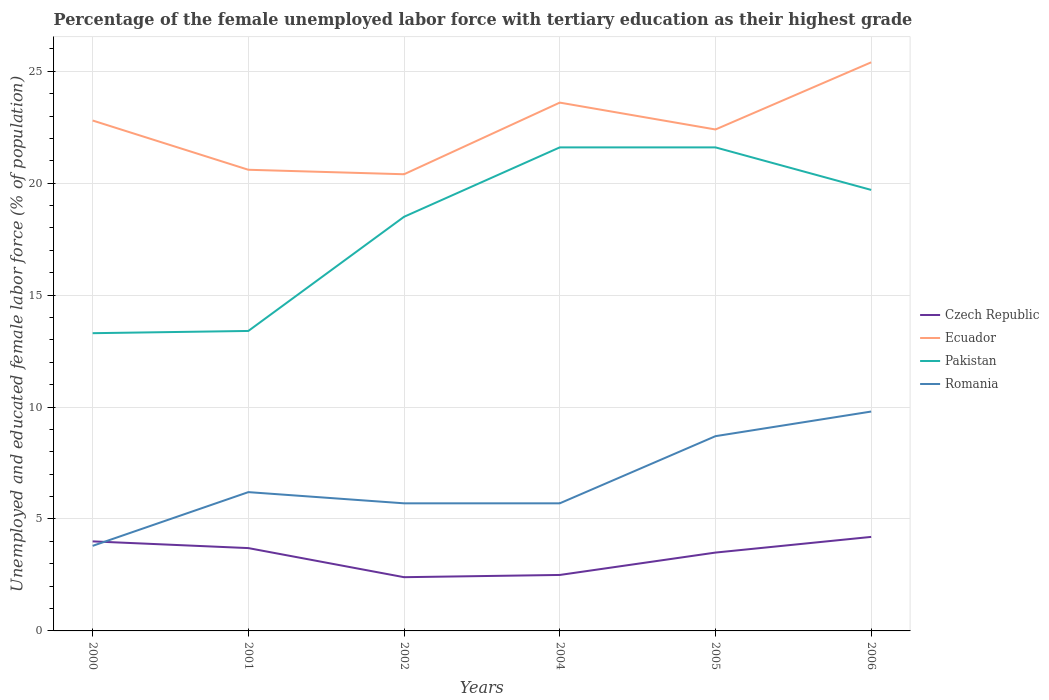How many different coloured lines are there?
Your answer should be compact. 4. Across all years, what is the maximum percentage of the unemployed female labor force with tertiary education in Romania?
Your answer should be compact. 3.8. What is the total percentage of the unemployed female labor force with tertiary education in Pakistan in the graph?
Make the answer very short. -6.4. What is the difference between the highest and the second highest percentage of the unemployed female labor force with tertiary education in Romania?
Provide a succinct answer. 6. What is the difference between the highest and the lowest percentage of the unemployed female labor force with tertiary education in Romania?
Your answer should be very brief. 2. How many years are there in the graph?
Give a very brief answer. 6. What is the difference between two consecutive major ticks on the Y-axis?
Ensure brevity in your answer.  5. Does the graph contain grids?
Offer a terse response. Yes. How many legend labels are there?
Ensure brevity in your answer.  4. How are the legend labels stacked?
Provide a short and direct response. Vertical. What is the title of the graph?
Provide a succinct answer. Percentage of the female unemployed labor force with tertiary education as their highest grade. What is the label or title of the X-axis?
Provide a succinct answer. Years. What is the label or title of the Y-axis?
Ensure brevity in your answer.  Unemployed and educated female labor force (% of population). What is the Unemployed and educated female labor force (% of population) of Ecuador in 2000?
Offer a very short reply. 22.8. What is the Unemployed and educated female labor force (% of population) in Pakistan in 2000?
Make the answer very short. 13.3. What is the Unemployed and educated female labor force (% of population) in Romania in 2000?
Ensure brevity in your answer.  3.8. What is the Unemployed and educated female labor force (% of population) of Czech Republic in 2001?
Ensure brevity in your answer.  3.7. What is the Unemployed and educated female labor force (% of population) in Ecuador in 2001?
Give a very brief answer. 20.6. What is the Unemployed and educated female labor force (% of population) in Pakistan in 2001?
Your answer should be very brief. 13.4. What is the Unemployed and educated female labor force (% of population) in Romania in 2001?
Offer a terse response. 6.2. What is the Unemployed and educated female labor force (% of population) of Czech Republic in 2002?
Give a very brief answer. 2.4. What is the Unemployed and educated female labor force (% of population) in Ecuador in 2002?
Provide a succinct answer. 20.4. What is the Unemployed and educated female labor force (% of population) of Romania in 2002?
Ensure brevity in your answer.  5.7. What is the Unemployed and educated female labor force (% of population) of Ecuador in 2004?
Offer a terse response. 23.6. What is the Unemployed and educated female labor force (% of population) of Pakistan in 2004?
Keep it short and to the point. 21.6. What is the Unemployed and educated female labor force (% of population) in Romania in 2004?
Your answer should be compact. 5.7. What is the Unemployed and educated female labor force (% of population) of Czech Republic in 2005?
Your answer should be compact. 3.5. What is the Unemployed and educated female labor force (% of population) of Ecuador in 2005?
Provide a succinct answer. 22.4. What is the Unemployed and educated female labor force (% of population) in Pakistan in 2005?
Your response must be concise. 21.6. What is the Unemployed and educated female labor force (% of population) of Romania in 2005?
Your answer should be compact. 8.7. What is the Unemployed and educated female labor force (% of population) of Czech Republic in 2006?
Offer a very short reply. 4.2. What is the Unemployed and educated female labor force (% of population) in Ecuador in 2006?
Keep it short and to the point. 25.4. What is the Unemployed and educated female labor force (% of population) of Pakistan in 2006?
Offer a very short reply. 19.7. What is the Unemployed and educated female labor force (% of population) of Romania in 2006?
Ensure brevity in your answer.  9.8. Across all years, what is the maximum Unemployed and educated female labor force (% of population) of Czech Republic?
Offer a terse response. 4.2. Across all years, what is the maximum Unemployed and educated female labor force (% of population) of Ecuador?
Your answer should be compact. 25.4. Across all years, what is the maximum Unemployed and educated female labor force (% of population) in Pakistan?
Give a very brief answer. 21.6. Across all years, what is the maximum Unemployed and educated female labor force (% of population) of Romania?
Ensure brevity in your answer.  9.8. Across all years, what is the minimum Unemployed and educated female labor force (% of population) of Czech Republic?
Offer a very short reply. 2.4. Across all years, what is the minimum Unemployed and educated female labor force (% of population) in Ecuador?
Provide a short and direct response. 20.4. Across all years, what is the minimum Unemployed and educated female labor force (% of population) in Pakistan?
Offer a very short reply. 13.3. Across all years, what is the minimum Unemployed and educated female labor force (% of population) in Romania?
Provide a short and direct response. 3.8. What is the total Unemployed and educated female labor force (% of population) of Czech Republic in the graph?
Give a very brief answer. 20.3. What is the total Unemployed and educated female labor force (% of population) of Ecuador in the graph?
Your answer should be compact. 135.2. What is the total Unemployed and educated female labor force (% of population) in Pakistan in the graph?
Make the answer very short. 108.1. What is the total Unemployed and educated female labor force (% of population) of Romania in the graph?
Make the answer very short. 39.9. What is the difference between the Unemployed and educated female labor force (% of population) in Romania in 2000 and that in 2001?
Keep it short and to the point. -2.4. What is the difference between the Unemployed and educated female labor force (% of population) in Ecuador in 2000 and that in 2002?
Provide a short and direct response. 2.4. What is the difference between the Unemployed and educated female labor force (% of population) in Romania in 2000 and that in 2002?
Your answer should be compact. -1.9. What is the difference between the Unemployed and educated female labor force (% of population) of Czech Republic in 2000 and that in 2005?
Give a very brief answer. 0.5. What is the difference between the Unemployed and educated female labor force (% of population) of Ecuador in 2000 and that in 2005?
Your answer should be very brief. 0.4. What is the difference between the Unemployed and educated female labor force (% of population) of Ecuador in 2000 and that in 2006?
Make the answer very short. -2.6. What is the difference between the Unemployed and educated female labor force (% of population) of Pakistan in 2000 and that in 2006?
Your answer should be compact. -6.4. What is the difference between the Unemployed and educated female labor force (% of population) in Ecuador in 2001 and that in 2002?
Ensure brevity in your answer.  0.2. What is the difference between the Unemployed and educated female labor force (% of population) in Romania in 2001 and that in 2002?
Provide a succinct answer. 0.5. What is the difference between the Unemployed and educated female labor force (% of population) of Czech Republic in 2001 and that in 2004?
Provide a succinct answer. 1.2. What is the difference between the Unemployed and educated female labor force (% of population) of Romania in 2001 and that in 2004?
Your response must be concise. 0.5. What is the difference between the Unemployed and educated female labor force (% of population) in Czech Republic in 2001 and that in 2005?
Offer a terse response. 0.2. What is the difference between the Unemployed and educated female labor force (% of population) in Ecuador in 2001 and that in 2005?
Provide a short and direct response. -1.8. What is the difference between the Unemployed and educated female labor force (% of population) in Czech Republic in 2001 and that in 2006?
Give a very brief answer. -0.5. What is the difference between the Unemployed and educated female labor force (% of population) of Ecuador in 2001 and that in 2006?
Your response must be concise. -4.8. What is the difference between the Unemployed and educated female labor force (% of population) of Czech Republic in 2002 and that in 2004?
Your response must be concise. -0.1. What is the difference between the Unemployed and educated female labor force (% of population) in Ecuador in 2002 and that in 2004?
Make the answer very short. -3.2. What is the difference between the Unemployed and educated female labor force (% of population) of Ecuador in 2002 and that in 2006?
Your response must be concise. -5. What is the difference between the Unemployed and educated female labor force (% of population) in Pakistan in 2002 and that in 2006?
Your answer should be compact. -1.2. What is the difference between the Unemployed and educated female labor force (% of population) in Czech Republic in 2004 and that in 2005?
Provide a succinct answer. -1. What is the difference between the Unemployed and educated female labor force (% of population) of Ecuador in 2004 and that in 2005?
Your answer should be very brief. 1.2. What is the difference between the Unemployed and educated female labor force (% of population) of Pakistan in 2004 and that in 2005?
Offer a terse response. 0. What is the difference between the Unemployed and educated female labor force (% of population) in Czech Republic in 2004 and that in 2006?
Offer a very short reply. -1.7. What is the difference between the Unemployed and educated female labor force (% of population) of Czech Republic in 2005 and that in 2006?
Your answer should be very brief. -0.7. What is the difference between the Unemployed and educated female labor force (% of population) in Romania in 2005 and that in 2006?
Keep it short and to the point. -1.1. What is the difference between the Unemployed and educated female labor force (% of population) of Czech Republic in 2000 and the Unemployed and educated female labor force (% of population) of Ecuador in 2001?
Give a very brief answer. -16.6. What is the difference between the Unemployed and educated female labor force (% of population) of Czech Republic in 2000 and the Unemployed and educated female labor force (% of population) of Pakistan in 2001?
Offer a terse response. -9.4. What is the difference between the Unemployed and educated female labor force (% of population) of Czech Republic in 2000 and the Unemployed and educated female labor force (% of population) of Romania in 2001?
Ensure brevity in your answer.  -2.2. What is the difference between the Unemployed and educated female labor force (% of population) of Ecuador in 2000 and the Unemployed and educated female labor force (% of population) of Pakistan in 2001?
Give a very brief answer. 9.4. What is the difference between the Unemployed and educated female labor force (% of population) in Ecuador in 2000 and the Unemployed and educated female labor force (% of population) in Romania in 2001?
Keep it short and to the point. 16.6. What is the difference between the Unemployed and educated female labor force (% of population) of Pakistan in 2000 and the Unemployed and educated female labor force (% of population) of Romania in 2001?
Provide a short and direct response. 7.1. What is the difference between the Unemployed and educated female labor force (% of population) of Czech Republic in 2000 and the Unemployed and educated female labor force (% of population) of Ecuador in 2002?
Make the answer very short. -16.4. What is the difference between the Unemployed and educated female labor force (% of population) of Pakistan in 2000 and the Unemployed and educated female labor force (% of population) of Romania in 2002?
Your answer should be very brief. 7.6. What is the difference between the Unemployed and educated female labor force (% of population) in Czech Republic in 2000 and the Unemployed and educated female labor force (% of population) in Ecuador in 2004?
Your answer should be compact. -19.6. What is the difference between the Unemployed and educated female labor force (% of population) in Czech Republic in 2000 and the Unemployed and educated female labor force (% of population) in Pakistan in 2004?
Your response must be concise. -17.6. What is the difference between the Unemployed and educated female labor force (% of population) of Czech Republic in 2000 and the Unemployed and educated female labor force (% of population) of Romania in 2004?
Ensure brevity in your answer.  -1.7. What is the difference between the Unemployed and educated female labor force (% of population) in Ecuador in 2000 and the Unemployed and educated female labor force (% of population) in Romania in 2004?
Offer a very short reply. 17.1. What is the difference between the Unemployed and educated female labor force (% of population) of Czech Republic in 2000 and the Unemployed and educated female labor force (% of population) of Ecuador in 2005?
Ensure brevity in your answer.  -18.4. What is the difference between the Unemployed and educated female labor force (% of population) of Czech Republic in 2000 and the Unemployed and educated female labor force (% of population) of Pakistan in 2005?
Offer a terse response. -17.6. What is the difference between the Unemployed and educated female labor force (% of population) in Czech Republic in 2000 and the Unemployed and educated female labor force (% of population) in Romania in 2005?
Your answer should be compact. -4.7. What is the difference between the Unemployed and educated female labor force (% of population) in Ecuador in 2000 and the Unemployed and educated female labor force (% of population) in Pakistan in 2005?
Provide a succinct answer. 1.2. What is the difference between the Unemployed and educated female labor force (% of population) of Czech Republic in 2000 and the Unemployed and educated female labor force (% of population) of Ecuador in 2006?
Provide a succinct answer. -21.4. What is the difference between the Unemployed and educated female labor force (% of population) in Czech Republic in 2000 and the Unemployed and educated female labor force (% of population) in Pakistan in 2006?
Your response must be concise. -15.7. What is the difference between the Unemployed and educated female labor force (% of population) of Czech Republic in 2000 and the Unemployed and educated female labor force (% of population) of Romania in 2006?
Provide a short and direct response. -5.8. What is the difference between the Unemployed and educated female labor force (% of population) in Ecuador in 2000 and the Unemployed and educated female labor force (% of population) in Pakistan in 2006?
Give a very brief answer. 3.1. What is the difference between the Unemployed and educated female labor force (% of population) in Pakistan in 2000 and the Unemployed and educated female labor force (% of population) in Romania in 2006?
Offer a very short reply. 3.5. What is the difference between the Unemployed and educated female labor force (% of population) in Czech Republic in 2001 and the Unemployed and educated female labor force (% of population) in Ecuador in 2002?
Give a very brief answer. -16.7. What is the difference between the Unemployed and educated female labor force (% of population) of Czech Republic in 2001 and the Unemployed and educated female labor force (% of population) of Pakistan in 2002?
Your response must be concise. -14.8. What is the difference between the Unemployed and educated female labor force (% of population) of Ecuador in 2001 and the Unemployed and educated female labor force (% of population) of Romania in 2002?
Your answer should be very brief. 14.9. What is the difference between the Unemployed and educated female labor force (% of population) of Czech Republic in 2001 and the Unemployed and educated female labor force (% of population) of Ecuador in 2004?
Give a very brief answer. -19.9. What is the difference between the Unemployed and educated female labor force (% of population) of Czech Republic in 2001 and the Unemployed and educated female labor force (% of population) of Pakistan in 2004?
Offer a terse response. -17.9. What is the difference between the Unemployed and educated female labor force (% of population) in Ecuador in 2001 and the Unemployed and educated female labor force (% of population) in Pakistan in 2004?
Your response must be concise. -1. What is the difference between the Unemployed and educated female labor force (% of population) in Czech Republic in 2001 and the Unemployed and educated female labor force (% of population) in Ecuador in 2005?
Offer a very short reply. -18.7. What is the difference between the Unemployed and educated female labor force (% of population) in Czech Republic in 2001 and the Unemployed and educated female labor force (% of population) in Pakistan in 2005?
Give a very brief answer. -17.9. What is the difference between the Unemployed and educated female labor force (% of population) in Czech Republic in 2001 and the Unemployed and educated female labor force (% of population) in Romania in 2005?
Give a very brief answer. -5. What is the difference between the Unemployed and educated female labor force (% of population) of Ecuador in 2001 and the Unemployed and educated female labor force (% of population) of Pakistan in 2005?
Provide a short and direct response. -1. What is the difference between the Unemployed and educated female labor force (% of population) of Czech Republic in 2001 and the Unemployed and educated female labor force (% of population) of Ecuador in 2006?
Offer a very short reply. -21.7. What is the difference between the Unemployed and educated female labor force (% of population) in Czech Republic in 2001 and the Unemployed and educated female labor force (% of population) in Pakistan in 2006?
Your answer should be compact. -16. What is the difference between the Unemployed and educated female labor force (% of population) in Ecuador in 2001 and the Unemployed and educated female labor force (% of population) in Pakistan in 2006?
Provide a succinct answer. 0.9. What is the difference between the Unemployed and educated female labor force (% of population) of Pakistan in 2001 and the Unemployed and educated female labor force (% of population) of Romania in 2006?
Keep it short and to the point. 3.6. What is the difference between the Unemployed and educated female labor force (% of population) in Czech Republic in 2002 and the Unemployed and educated female labor force (% of population) in Ecuador in 2004?
Make the answer very short. -21.2. What is the difference between the Unemployed and educated female labor force (% of population) in Czech Republic in 2002 and the Unemployed and educated female labor force (% of population) in Pakistan in 2004?
Provide a succinct answer. -19.2. What is the difference between the Unemployed and educated female labor force (% of population) in Czech Republic in 2002 and the Unemployed and educated female labor force (% of population) in Romania in 2004?
Your answer should be compact. -3.3. What is the difference between the Unemployed and educated female labor force (% of population) in Ecuador in 2002 and the Unemployed and educated female labor force (% of population) in Romania in 2004?
Make the answer very short. 14.7. What is the difference between the Unemployed and educated female labor force (% of population) in Czech Republic in 2002 and the Unemployed and educated female labor force (% of population) in Ecuador in 2005?
Offer a very short reply. -20. What is the difference between the Unemployed and educated female labor force (% of population) of Czech Republic in 2002 and the Unemployed and educated female labor force (% of population) of Pakistan in 2005?
Offer a terse response. -19.2. What is the difference between the Unemployed and educated female labor force (% of population) in Czech Republic in 2002 and the Unemployed and educated female labor force (% of population) in Romania in 2005?
Provide a succinct answer. -6.3. What is the difference between the Unemployed and educated female labor force (% of population) of Pakistan in 2002 and the Unemployed and educated female labor force (% of population) of Romania in 2005?
Keep it short and to the point. 9.8. What is the difference between the Unemployed and educated female labor force (% of population) in Czech Republic in 2002 and the Unemployed and educated female labor force (% of population) in Pakistan in 2006?
Make the answer very short. -17.3. What is the difference between the Unemployed and educated female labor force (% of population) of Ecuador in 2002 and the Unemployed and educated female labor force (% of population) of Pakistan in 2006?
Make the answer very short. 0.7. What is the difference between the Unemployed and educated female labor force (% of population) in Pakistan in 2002 and the Unemployed and educated female labor force (% of population) in Romania in 2006?
Offer a very short reply. 8.7. What is the difference between the Unemployed and educated female labor force (% of population) in Czech Republic in 2004 and the Unemployed and educated female labor force (% of population) in Ecuador in 2005?
Keep it short and to the point. -19.9. What is the difference between the Unemployed and educated female labor force (% of population) in Czech Republic in 2004 and the Unemployed and educated female labor force (% of population) in Pakistan in 2005?
Your answer should be compact. -19.1. What is the difference between the Unemployed and educated female labor force (% of population) in Pakistan in 2004 and the Unemployed and educated female labor force (% of population) in Romania in 2005?
Your response must be concise. 12.9. What is the difference between the Unemployed and educated female labor force (% of population) in Czech Republic in 2004 and the Unemployed and educated female labor force (% of population) in Ecuador in 2006?
Keep it short and to the point. -22.9. What is the difference between the Unemployed and educated female labor force (% of population) in Czech Republic in 2004 and the Unemployed and educated female labor force (% of population) in Pakistan in 2006?
Offer a very short reply. -17.2. What is the difference between the Unemployed and educated female labor force (% of population) in Czech Republic in 2004 and the Unemployed and educated female labor force (% of population) in Romania in 2006?
Provide a short and direct response. -7.3. What is the difference between the Unemployed and educated female labor force (% of population) in Ecuador in 2004 and the Unemployed and educated female labor force (% of population) in Pakistan in 2006?
Provide a short and direct response. 3.9. What is the difference between the Unemployed and educated female labor force (% of population) in Czech Republic in 2005 and the Unemployed and educated female labor force (% of population) in Ecuador in 2006?
Your response must be concise. -21.9. What is the difference between the Unemployed and educated female labor force (% of population) in Czech Republic in 2005 and the Unemployed and educated female labor force (% of population) in Pakistan in 2006?
Keep it short and to the point. -16.2. What is the difference between the Unemployed and educated female labor force (% of population) of Ecuador in 2005 and the Unemployed and educated female labor force (% of population) of Romania in 2006?
Ensure brevity in your answer.  12.6. What is the average Unemployed and educated female labor force (% of population) of Czech Republic per year?
Give a very brief answer. 3.38. What is the average Unemployed and educated female labor force (% of population) in Ecuador per year?
Offer a terse response. 22.53. What is the average Unemployed and educated female labor force (% of population) in Pakistan per year?
Offer a very short reply. 18.02. What is the average Unemployed and educated female labor force (% of population) in Romania per year?
Provide a short and direct response. 6.65. In the year 2000, what is the difference between the Unemployed and educated female labor force (% of population) in Czech Republic and Unemployed and educated female labor force (% of population) in Ecuador?
Keep it short and to the point. -18.8. In the year 2000, what is the difference between the Unemployed and educated female labor force (% of population) of Czech Republic and Unemployed and educated female labor force (% of population) of Romania?
Ensure brevity in your answer.  0.2. In the year 2000, what is the difference between the Unemployed and educated female labor force (% of population) of Ecuador and Unemployed and educated female labor force (% of population) of Pakistan?
Offer a very short reply. 9.5. In the year 2000, what is the difference between the Unemployed and educated female labor force (% of population) in Pakistan and Unemployed and educated female labor force (% of population) in Romania?
Offer a very short reply. 9.5. In the year 2001, what is the difference between the Unemployed and educated female labor force (% of population) in Czech Republic and Unemployed and educated female labor force (% of population) in Ecuador?
Your answer should be compact. -16.9. In the year 2001, what is the difference between the Unemployed and educated female labor force (% of population) in Czech Republic and Unemployed and educated female labor force (% of population) in Romania?
Offer a terse response. -2.5. In the year 2001, what is the difference between the Unemployed and educated female labor force (% of population) in Ecuador and Unemployed and educated female labor force (% of population) in Pakistan?
Keep it short and to the point. 7.2. In the year 2001, what is the difference between the Unemployed and educated female labor force (% of population) of Ecuador and Unemployed and educated female labor force (% of population) of Romania?
Your response must be concise. 14.4. In the year 2001, what is the difference between the Unemployed and educated female labor force (% of population) of Pakistan and Unemployed and educated female labor force (% of population) of Romania?
Provide a short and direct response. 7.2. In the year 2002, what is the difference between the Unemployed and educated female labor force (% of population) of Czech Republic and Unemployed and educated female labor force (% of population) of Ecuador?
Keep it short and to the point. -18. In the year 2002, what is the difference between the Unemployed and educated female labor force (% of population) of Czech Republic and Unemployed and educated female labor force (% of population) of Pakistan?
Your response must be concise. -16.1. In the year 2002, what is the difference between the Unemployed and educated female labor force (% of population) in Ecuador and Unemployed and educated female labor force (% of population) in Pakistan?
Provide a succinct answer. 1.9. In the year 2002, what is the difference between the Unemployed and educated female labor force (% of population) of Ecuador and Unemployed and educated female labor force (% of population) of Romania?
Your answer should be very brief. 14.7. In the year 2004, what is the difference between the Unemployed and educated female labor force (% of population) in Czech Republic and Unemployed and educated female labor force (% of population) in Ecuador?
Offer a very short reply. -21.1. In the year 2004, what is the difference between the Unemployed and educated female labor force (% of population) of Czech Republic and Unemployed and educated female labor force (% of population) of Pakistan?
Your response must be concise. -19.1. In the year 2004, what is the difference between the Unemployed and educated female labor force (% of population) in Ecuador and Unemployed and educated female labor force (% of population) in Pakistan?
Make the answer very short. 2. In the year 2004, what is the difference between the Unemployed and educated female labor force (% of population) of Ecuador and Unemployed and educated female labor force (% of population) of Romania?
Your response must be concise. 17.9. In the year 2004, what is the difference between the Unemployed and educated female labor force (% of population) in Pakistan and Unemployed and educated female labor force (% of population) in Romania?
Offer a very short reply. 15.9. In the year 2005, what is the difference between the Unemployed and educated female labor force (% of population) of Czech Republic and Unemployed and educated female labor force (% of population) of Ecuador?
Your response must be concise. -18.9. In the year 2005, what is the difference between the Unemployed and educated female labor force (% of population) in Czech Republic and Unemployed and educated female labor force (% of population) in Pakistan?
Keep it short and to the point. -18.1. In the year 2006, what is the difference between the Unemployed and educated female labor force (% of population) in Czech Republic and Unemployed and educated female labor force (% of population) in Ecuador?
Your answer should be very brief. -21.2. In the year 2006, what is the difference between the Unemployed and educated female labor force (% of population) in Czech Republic and Unemployed and educated female labor force (% of population) in Pakistan?
Provide a short and direct response. -15.5. In the year 2006, what is the difference between the Unemployed and educated female labor force (% of population) of Czech Republic and Unemployed and educated female labor force (% of population) of Romania?
Make the answer very short. -5.6. In the year 2006, what is the difference between the Unemployed and educated female labor force (% of population) in Ecuador and Unemployed and educated female labor force (% of population) in Pakistan?
Ensure brevity in your answer.  5.7. In the year 2006, what is the difference between the Unemployed and educated female labor force (% of population) of Ecuador and Unemployed and educated female labor force (% of population) of Romania?
Offer a very short reply. 15.6. In the year 2006, what is the difference between the Unemployed and educated female labor force (% of population) in Pakistan and Unemployed and educated female labor force (% of population) in Romania?
Offer a terse response. 9.9. What is the ratio of the Unemployed and educated female labor force (% of population) in Czech Republic in 2000 to that in 2001?
Your answer should be very brief. 1.08. What is the ratio of the Unemployed and educated female labor force (% of population) of Ecuador in 2000 to that in 2001?
Provide a succinct answer. 1.11. What is the ratio of the Unemployed and educated female labor force (% of population) of Romania in 2000 to that in 2001?
Give a very brief answer. 0.61. What is the ratio of the Unemployed and educated female labor force (% of population) of Ecuador in 2000 to that in 2002?
Offer a terse response. 1.12. What is the ratio of the Unemployed and educated female labor force (% of population) in Pakistan in 2000 to that in 2002?
Keep it short and to the point. 0.72. What is the ratio of the Unemployed and educated female labor force (% of population) of Czech Republic in 2000 to that in 2004?
Your answer should be very brief. 1.6. What is the ratio of the Unemployed and educated female labor force (% of population) of Ecuador in 2000 to that in 2004?
Offer a very short reply. 0.97. What is the ratio of the Unemployed and educated female labor force (% of population) in Pakistan in 2000 to that in 2004?
Your answer should be compact. 0.62. What is the ratio of the Unemployed and educated female labor force (% of population) of Romania in 2000 to that in 2004?
Provide a short and direct response. 0.67. What is the ratio of the Unemployed and educated female labor force (% of population) of Czech Republic in 2000 to that in 2005?
Provide a short and direct response. 1.14. What is the ratio of the Unemployed and educated female labor force (% of population) in Ecuador in 2000 to that in 2005?
Make the answer very short. 1.02. What is the ratio of the Unemployed and educated female labor force (% of population) of Pakistan in 2000 to that in 2005?
Offer a very short reply. 0.62. What is the ratio of the Unemployed and educated female labor force (% of population) in Romania in 2000 to that in 2005?
Your response must be concise. 0.44. What is the ratio of the Unemployed and educated female labor force (% of population) in Ecuador in 2000 to that in 2006?
Your answer should be compact. 0.9. What is the ratio of the Unemployed and educated female labor force (% of population) of Pakistan in 2000 to that in 2006?
Your answer should be compact. 0.68. What is the ratio of the Unemployed and educated female labor force (% of population) in Romania in 2000 to that in 2006?
Give a very brief answer. 0.39. What is the ratio of the Unemployed and educated female labor force (% of population) in Czech Republic in 2001 to that in 2002?
Offer a very short reply. 1.54. What is the ratio of the Unemployed and educated female labor force (% of population) in Ecuador in 2001 to that in 2002?
Your answer should be very brief. 1.01. What is the ratio of the Unemployed and educated female labor force (% of population) of Pakistan in 2001 to that in 2002?
Ensure brevity in your answer.  0.72. What is the ratio of the Unemployed and educated female labor force (% of population) in Romania in 2001 to that in 2002?
Give a very brief answer. 1.09. What is the ratio of the Unemployed and educated female labor force (% of population) in Czech Republic in 2001 to that in 2004?
Provide a short and direct response. 1.48. What is the ratio of the Unemployed and educated female labor force (% of population) in Ecuador in 2001 to that in 2004?
Provide a succinct answer. 0.87. What is the ratio of the Unemployed and educated female labor force (% of population) of Pakistan in 2001 to that in 2004?
Make the answer very short. 0.62. What is the ratio of the Unemployed and educated female labor force (% of population) in Romania in 2001 to that in 2004?
Keep it short and to the point. 1.09. What is the ratio of the Unemployed and educated female labor force (% of population) in Czech Republic in 2001 to that in 2005?
Your answer should be very brief. 1.06. What is the ratio of the Unemployed and educated female labor force (% of population) of Ecuador in 2001 to that in 2005?
Provide a succinct answer. 0.92. What is the ratio of the Unemployed and educated female labor force (% of population) of Pakistan in 2001 to that in 2005?
Your answer should be very brief. 0.62. What is the ratio of the Unemployed and educated female labor force (% of population) of Romania in 2001 to that in 2005?
Your answer should be very brief. 0.71. What is the ratio of the Unemployed and educated female labor force (% of population) in Czech Republic in 2001 to that in 2006?
Ensure brevity in your answer.  0.88. What is the ratio of the Unemployed and educated female labor force (% of population) in Ecuador in 2001 to that in 2006?
Your answer should be very brief. 0.81. What is the ratio of the Unemployed and educated female labor force (% of population) in Pakistan in 2001 to that in 2006?
Offer a terse response. 0.68. What is the ratio of the Unemployed and educated female labor force (% of population) of Romania in 2001 to that in 2006?
Offer a terse response. 0.63. What is the ratio of the Unemployed and educated female labor force (% of population) of Ecuador in 2002 to that in 2004?
Provide a short and direct response. 0.86. What is the ratio of the Unemployed and educated female labor force (% of population) in Pakistan in 2002 to that in 2004?
Give a very brief answer. 0.86. What is the ratio of the Unemployed and educated female labor force (% of population) of Czech Republic in 2002 to that in 2005?
Keep it short and to the point. 0.69. What is the ratio of the Unemployed and educated female labor force (% of population) of Ecuador in 2002 to that in 2005?
Offer a terse response. 0.91. What is the ratio of the Unemployed and educated female labor force (% of population) of Pakistan in 2002 to that in 2005?
Keep it short and to the point. 0.86. What is the ratio of the Unemployed and educated female labor force (% of population) of Romania in 2002 to that in 2005?
Give a very brief answer. 0.66. What is the ratio of the Unemployed and educated female labor force (% of population) of Ecuador in 2002 to that in 2006?
Ensure brevity in your answer.  0.8. What is the ratio of the Unemployed and educated female labor force (% of population) of Pakistan in 2002 to that in 2006?
Your response must be concise. 0.94. What is the ratio of the Unemployed and educated female labor force (% of population) of Romania in 2002 to that in 2006?
Provide a short and direct response. 0.58. What is the ratio of the Unemployed and educated female labor force (% of population) in Czech Republic in 2004 to that in 2005?
Give a very brief answer. 0.71. What is the ratio of the Unemployed and educated female labor force (% of population) of Ecuador in 2004 to that in 2005?
Offer a very short reply. 1.05. What is the ratio of the Unemployed and educated female labor force (% of population) in Pakistan in 2004 to that in 2005?
Your answer should be compact. 1. What is the ratio of the Unemployed and educated female labor force (% of population) in Romania in 2004 to that in 2005?
Give a very brief answer. 0.66. What is the ratio of the Unemployed and educated female labor force (% of population) in Czech Republic in 2004 to that in 2006?
Keep it short and to the point. 0.6. What is the ratio of the Unemployed and educated female labor force (% of population) in Ecuador in 2004 to that in 2006?
Keep it short and to the point. 0.93. What is the ratio of the Unemployed and educated female labor force (% of population) of Pakistan in 2004 to that in 2006?
Offer a very short reply. 1.1. What is the ratio of the Unemployed and educated female labor force (% of population) in Romania in 2004 to that in 2006?
Offer a very short reply. 0.58. What is the ratio of the Unemployed and educated female labor force (% of population) of Czech Republic in 2005 to that in 2006?
Keep it short and to the point. 0.83. What is the ratio of the Unemployed and educated female labor force (% of population) of Ecuador in 2005 to that in 2006?
Provide a succinct answer. 0.88. What is the ratio of the Unemployed and educated female labor force (% of population) in Pakistan in 2005 to that in 2006?
Give a very brief answer. 1.1. What is the ratio of the Unemployed and educated female labor force (% of population) of Romania in 2005 to that in 2006?
Offer a very short reply. 0.89. What is the difference between the highest and the lowest Unemployed and educated female labor force (% of population) of Ecuador?
Offer a terse response. 5. What is the difference between the highest and the lowest Unemployed and educated female labor force (% of population) in Romania?
Offer a terse response. 6. 